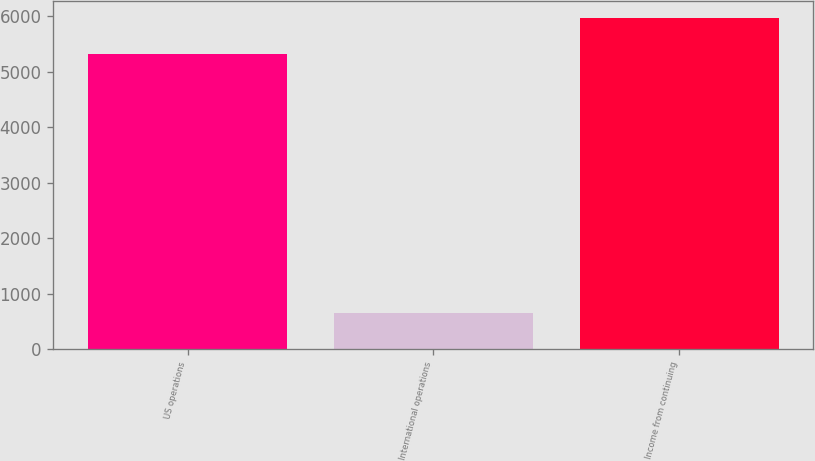Convert chart to OTSL. <chart><loc_0><loc_0><loc_500><loc_500><bar_chart><fcel>US operations<fcel>International operations<fcel>Income from continuing<nl><fcel>5327<fcel>644<fcel>5971<nl></chart> 